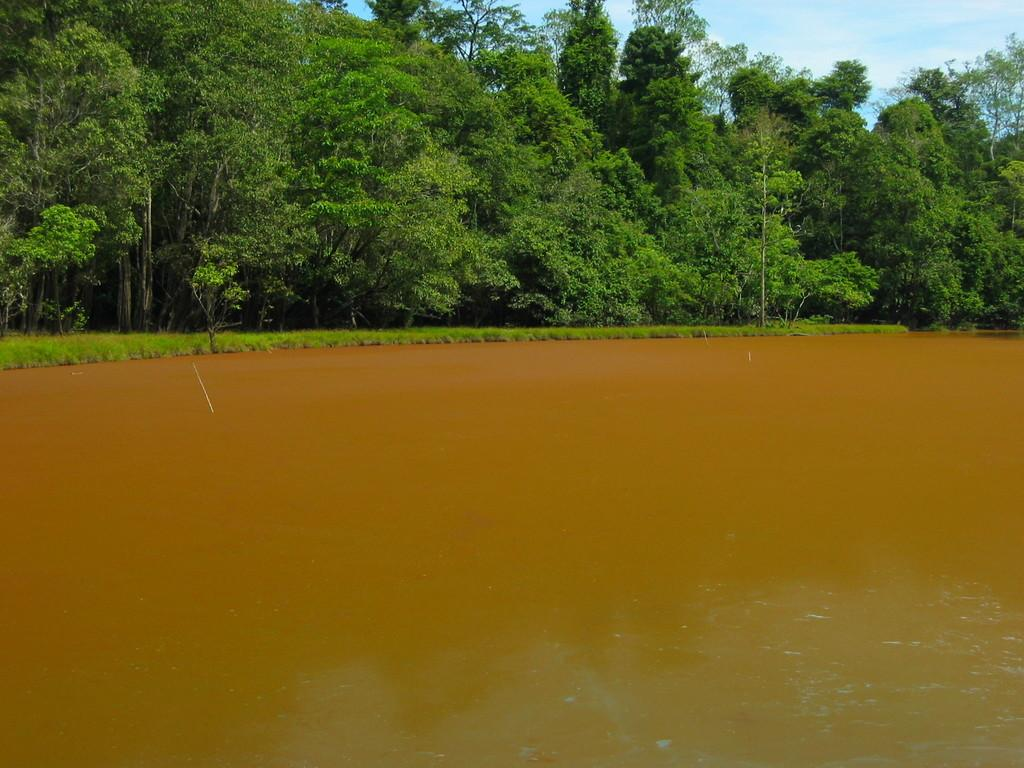What type of natural feature is at the bottom of the image? There is a river at the bottom of the image. What can be seen in the background of the image? There are trees in the background of the image. What is visible at the top of the image? The sky is visible at the top of the image. What type of wool can be seen growing on the edge of the river in the image? There is no wool or any reference to wool in the image; it features a river, trees, and the sky. What part of the brain is visible in the image? There is no brain or any reference to a brain in the image; it features a river, trees, and the sky. 